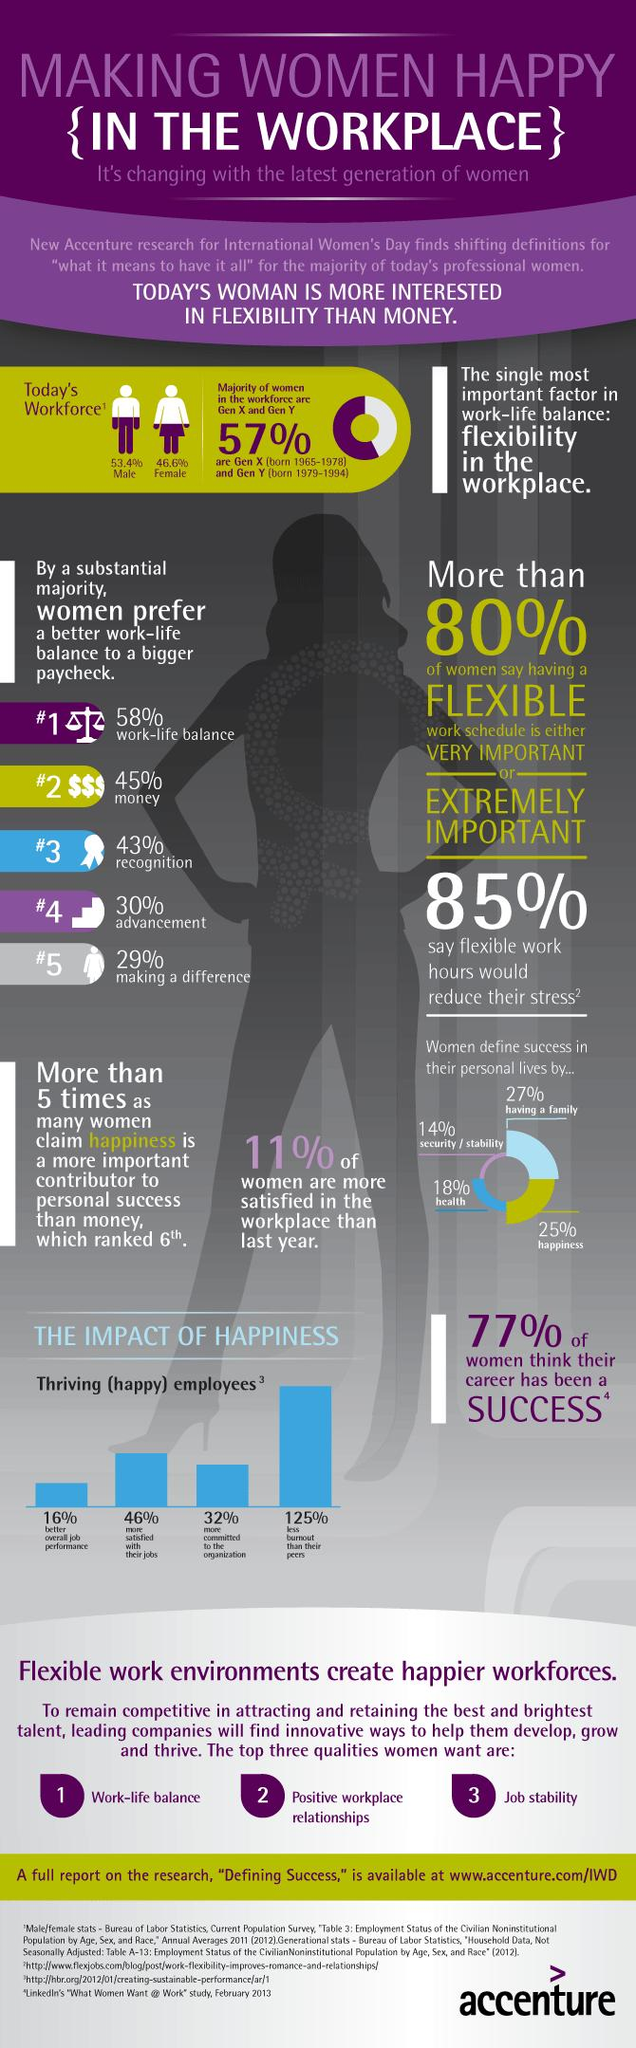List a handful of essential elements in this visual. The level of exhaustion from a job is the largest indicator of the impact of happiness, with low exhaustion being associated with high levels of happiness in relation to other factors such as low commitment, low satisfaction, and high job satisfaction. According to the data, 25% of women believe that being happy is the ultimate measure of success, while 14% and 18% respectively hold this view to a lesser extent. 